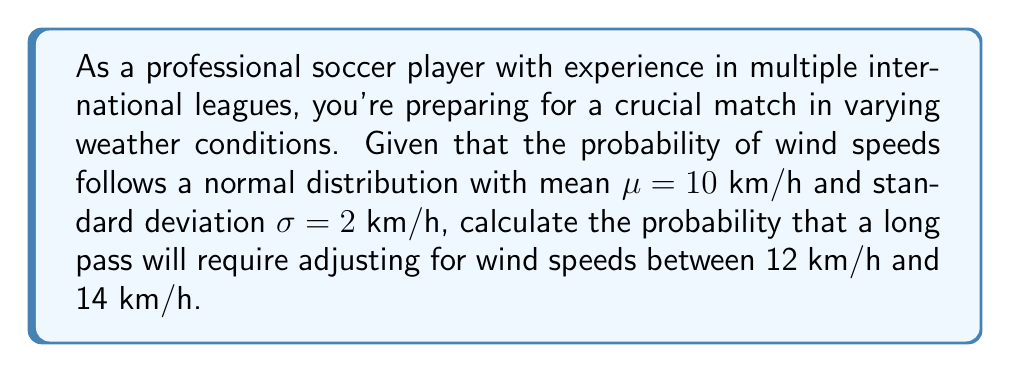Show me your answer to this math problem. To solve this problem, we'll use the properties of the normal distribution and the concept of z-scores.

Step 1: Standardize the given wind speed range.
Lower bound: $z_1 = \frac{12 - 10}{2} = 1$
Upper bound: $z_2 = \frac{14 - 10}{2} = 2$

Step 2: Use the standard normal distribution table or a calculator to find the area under the curve between these z-scores.

$P(12 < X < 14) = P(1 < Z < 2)$

Step 3: Calculate the probabilities for each z-score.
$P(Z < 1) \approx 0.8413$
$P(Z < 2) \approx 0.9772$

Step 4: Subtract to find the probability between the two z-scores.
$P(1 < Z < 2) = P(Z < 2) - P(Z < 1)$
$P(1 < Z < 2) = 0.9772 - 0.8413 = 0.1359$

Therefore, the probability of wind speeds between 12 km/h and 14 km/h is approximately 0.1359 or 13.59%.
Answer: 0.1359 or 13.59% 